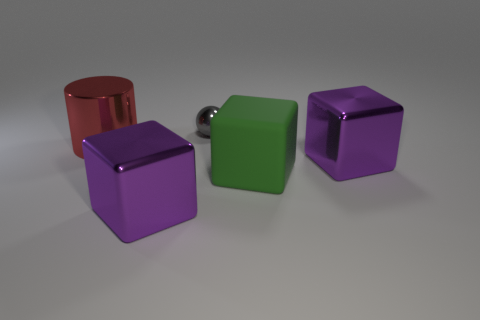Subtract all green cubes. How many cubes are left? 2 Subtract all gray spheres. How many purple cubes are left? 2 Add 5 blue balls. How many objects exist? 10 Subtract all spheres. How many objects are left? 4 Add 4 big green blocks. How many big green blocks are left? 5 Add 5 large red metal things. How many large red metal things exist? 6 Subtract 1 red cylinders. How many objects are left? 4 Subtract all brown cubes. Subtract all gray balls. How many cubes are left? 3 Subtract all large green blocks. Subtract all large red things. How many objects are left? 3 